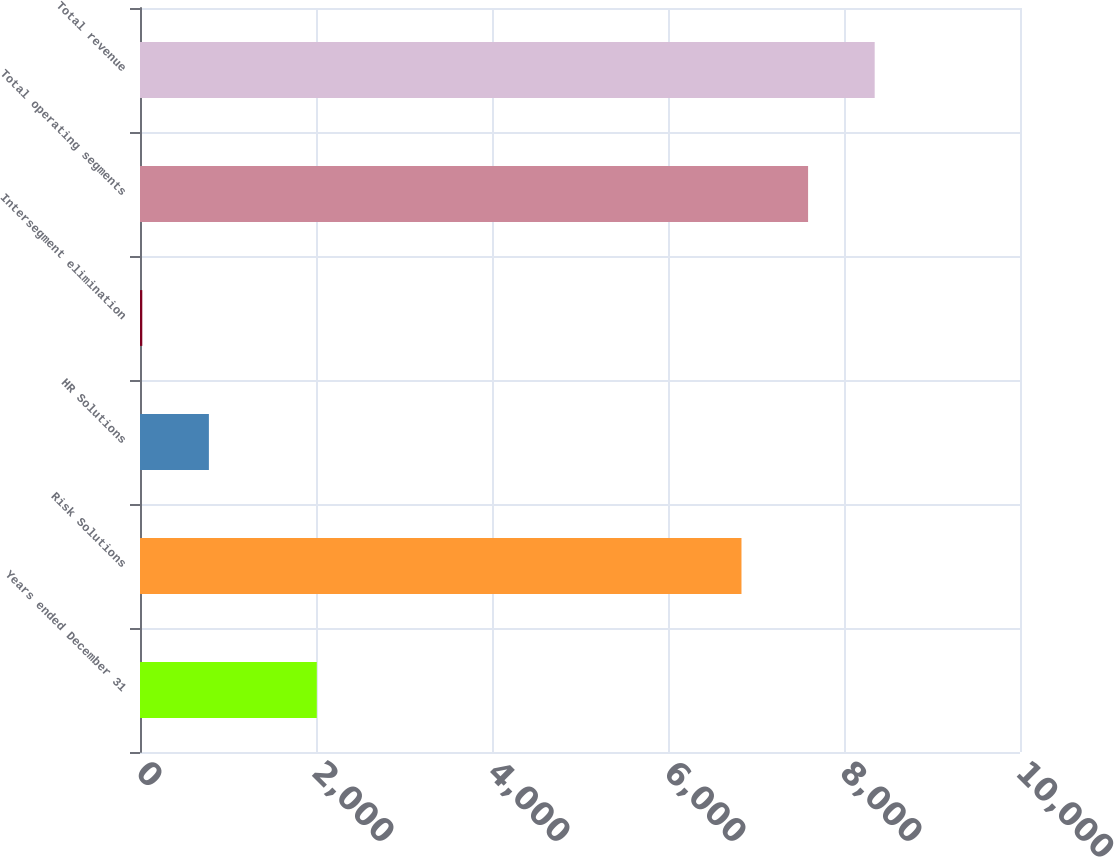<chart> <loc_0><loc_0><loc_500><loc_500><bar_chart><fcel>Years ended December 31<fcel>Risk Solutions<fcel>HR Solutions<fcel>Intersegment elimination<fcel>Total operating segments<fcel>Total revenue<nl><fcel>2009<fcel>6835<fcel>782.9<fcel>26<fcel>7591.9<fcel>8348.8<nl></chart> 